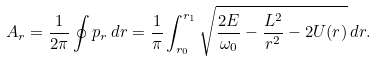<formula> <loc_0><loc_0><loc_500><loc_500>A _ { r } = \frac { 1 } { 2 \pi } \oint p _ { r } \, d r = \frac { 1 } { \pi } \int _ { r _ { 0 } } ^ { r _ { 1 } } \sqrt { \frac { 2 E } { \omega _ { 0 } } - \frac { L ^ { 2 } } { r ^ { 2 } } - 2 U ( r ) } \, d r .</formula> 